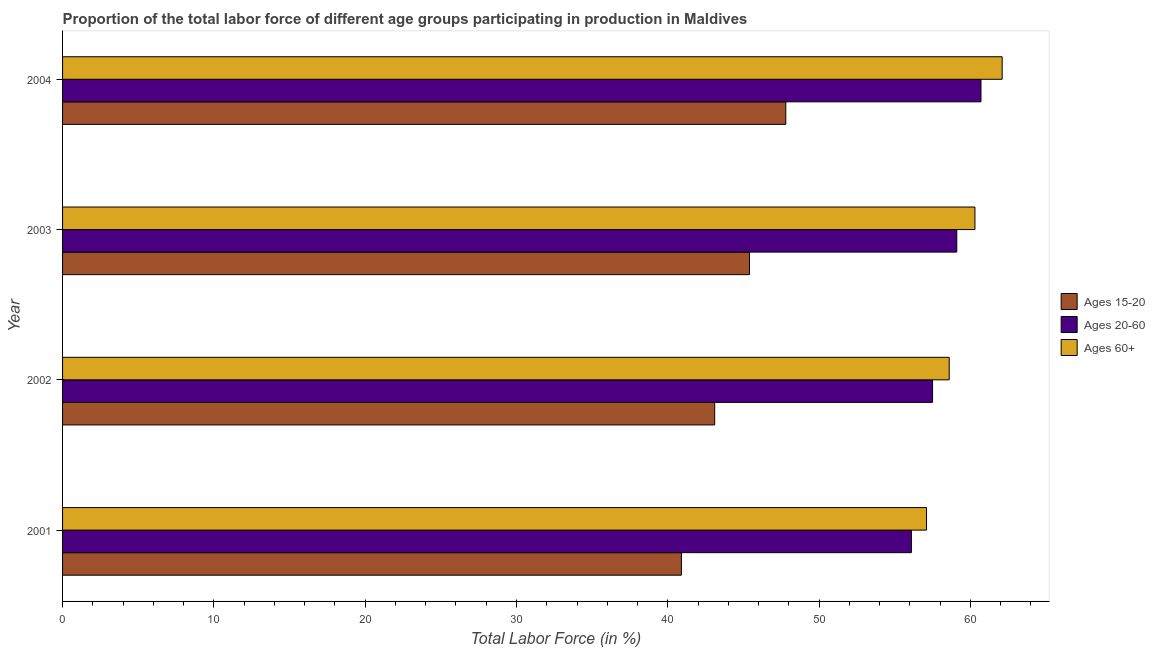Are the number of bars on each tick of the Y-axis equal?
Offer a very short reply. Yes. What is the label of the 2nd group of bars from the top?
Offer a very short reply. 2003. What is the percentage of labor force within the age group 15-20 in 2004?
Your answer should be compact. 47.8. Across all years, what is the maximum percentage of labor force above age 60?
Make the answer very short. 62.1. Across all years, what is the minimum percentage of labor force above age 60?
Offer a very short reply. 57.1. In which year was the percentage of labor force within the age group 15-20 minimum?
Your response must be concise. 2001. What is the total percentage of labor force within the age group 20-60 in the graph?
Your answer should be compact. 233.4. What is the difference between the percentage of labor force within the age group 15-20 in 2003 and that in 2004?
Give a very brief answer. -2.4. What is the difference between the percentage of labor force within the age group 15-20 in 2001 and the percentage of labor force above age 60 in 2003?
Provide a short and direct response. -19.4. What is the average percentage of labor force within the age group 20-60 per year?
Offer a very short reply. 58.35. In the year 2001, what is the difference between the percentage of labor force above age 60 and percentage of labor force within the age group 20-60?
Your answer should be very brief. 1. In how many years, is the percentage of labor force above age 60 greater than 20 %?
Make the answer very short. 4. What is the ratio of the percentage of labor force within the age group 20-60 in 2002 to that in 2003?
Keep it short and to the point. 0.97. What is the difference between the highest and the lowest percentage of labor force within the age group 15-20?
Your answer should be very brief. 6.9. What does the 1st bar from the top in 2003 represents?
Offer a terse response. Ages 60+. What does the 1st bar from the bottom in 2003 represents?
Offer a very short reply. Ages 15-20. How many bars are there?
Offer a very short reply. 12. What is the difference between two consecutive major ticks on the X-axis?
Give a very brief answer. 10. Does the graph contain any zero values?
Provide a short and direct response. No. Does the graph contain grids?
Keep it short and to the point. No. How many legend labels are there?
Your answer should be very brief. 3. How are the legend labels stacked?
Offer a very short reply. Vertical. What is the title of the graph?
Your response must be concise. Proportion of the total labor force of different age groups participating in production in Maldives. What is the label or title of the X-axis?
Provide a succinct answer. Total Labor Force (in %). What is the label or title of the Y-axis?
Make the answer very short. Year. What is the Total Labor Force (in %) in Ages 15-20 in 2001?
Ensure brevity in your answer.  40.9. What is the Total Labor Force (in %) in Ages 20-60 in 2001?
Give a very brief answer. 56.1. What is the Total Labor Force (in %) in Ages 60+ in 2001?
Provide a short and direct response. 57.1. What is the Total Labor Force (in %) of Ages 15-20 in 2002?
Your response must be concise. 43.1. What is the Total Labor Force (in %) in Ages 20-60 in 2002?
Keep it short and to the point. 57.5. What is the Total Labor Force (in %) in Ages 60+ in 2002?
Your answer should be compact. 58.6. What is the Total Labor Force (in %) in Ages 15-20 in 2003?
Make the answer very short. 45.4. What is the Total Labor Force (in %) in Ages 20-60 in 2003?
Offer a very short reply. 59.1. What is the Total Labor Force (in %) of Ages 60+ in 2003?
Give a very brief answer. 60.3. What is the Total Labor Force (in %) in Ages 15-20 in 2004?
Your response must be concise. 47.8. What is the Total Labor Force (in %) of Ages 20-60 in 2004?
Give a very brief answer. 60.7. What is the Total Labor Force (in %) in Ages 60+ in 2004?
Provide a succinct answer. 62.1. Across all years, what is the maximum Total Labor Force (in %) in Ages 15-20?
Make the answer very short. 47.8. Across all years, what is the maximum Total Labor Force (in %) in Ages 20-60?
Your answer should be very brief. 60.7. Across all years, what is the maximum Total Labor Force (in %) of Ages 60+?
Provide a short and direct response. 62.1. Across all years, what is the minimum Total Labor Force (in %) in Ages 15-20?
Offer a very short reply. 40.9. Across all years, what is the minimum Total Labor Force (in %) in Ages 20-60?
Provide a short and direct response. 56.1. Across all years, what is the minimum Total Labor Force (in %) of Ages 60+?
Give a very brief answer. 57.1. What is the total Total Labor Force (in %) of Ages 15-20 in the graph?
Offer a very short reply. 177.2. What is the total Total Labor Force (in %) of Ages 20-60 in the graph?
Provide a succinct answer. 233.4. What is the total Total Labor Force (in %) in Ages 60+ in the graph?
Offer a terse response. 238.1. What is the difference between the Total Labor Force (in %) of Ages 20-60 in 2001 and that in 2002?
Ensure brevity in your answer.  -1.4. What is the difference between the Total Labor Force (in %) in Ages 20-60 in 2001 and that in 2003?
Your answer should be compact. -3. What is the difference between the Total Labor Force (in %) of Ages 60+ in 2001 and that in 2004?
Provide a succinct answer. -5. What is the difference between the Total Labor Force (in %) of Ages 20-60 in 2002 and that in 2004?
Your response must be concise. -3.2. What is the difference between the Total Labor Force (in %) of Ages 15-20 in 2003 and that in 2004?
Your answer should be very brief. -2.4. What is the difference between the Total Labor Force (in %) in Ages 20-60 in 2003 and that in 2004?
Offer a terse response. -1.6. What is the difference between the Total Labor Force (in %) of Ages 15-20 in 2001 and the Total Labor Force (in %) of Ages 20-60 in 2002?
Make the answer very short. -16.6. What is the difference between the Total Labor Force (in %) of Ages 15-20 in 2001 and the Total Labor Force (in %) of Ages 60+ in 2002?
Provide a short and direct response. -17.7. What is the difference between the Total Labor Force (in %) in Ages 15-20 in 2001 and the Total Labor Force (in %) in Ages 20-60 in 2003?
Offer a very short reply. -18.2. What is the difference between the Total Labor Force (in %) of Ages 15-20 in 2001 and the Total Labor Force (in %) of Ages 60+ in 2003?
Keep it short and to the point. -19.4. What is the difference between the Total Labor Force (in %) in Ages 20-60 in 2001 and the Total Labor Force (in %) in Ages 60+ in 2003?
Ensure brevity in your answer.  -4.2. What is the difference between the Total Labor Force (in %) in Ages 15-20 in 2001 and the Total Labor Force (in %) in Ages 20-60 in 2004?
Your response must be concise. -19.8. What is the difference between the Total Labor Force (in %) in Ages 15-20 in 2001 and the Total Labor Force (in %) in Ages 60+ in 2004?
Provide a succinct answer. -21.2. What is the difference between the Total Labor Force (in %) of Ages 20-60 in 2001 and the Total Labor Force (in %) of Ages 60+ in 2004?
Your answer should be compact. -6. What is the difference between the Total Labor Force (in %) of Ages 15-20 in 2002 and the Total Labor Force (in %) of Ages 20-60 in 2003?
Provide a short and direct response. -16. What is the difference between the Total Labor Force (in %) in Ages 15-20 in 2002 and the Total Labor Force (in %) in Ages 60+ in 2003?
Your answer should be compact. -17.2. What is the difference between the Total Labor Force (in %) in Ages 20-60 in 2002 and the Total Labor Force (in %) in Ages 60+ in 2003?
Provide a succinct answer. -2.8. What is the difference between the Total Labor Force (in %) of Ages 15-20 in 2002 and the Total Labor Force (in %) of Ages 20-60 in 2004?
Provide a short and direct response. -17.6. What is the difference between the Total Labor Force (in %) in Ages 15-20 in 2002 and the Total Labor Force (in %) in Ages 60+ in 2004?
Offer a terse response. -19. What is the difference between the Total Labor Force (in %) in Ages 20-60 in 2002 and the Total Labor Force (in %) in Ages 60+ in 2004?
Make the answer very short. -4.6. What is the difference between the Total Labor Force (in %) of Ages 15-20 in 2003 and the Total Labor Force (in %) of Ages 20-60 in 2004?
Offer a very short reply. -15.3. What is the difference between the Total Labor Force (in %) of Ages 15-20 in 2003 and the Total Labor Force (in %) of Ages 60+ in 2004?
Provide a short and direct response. -16.7. What is the average Total Labor Force (in %) in Ages 15-20 per year?
Offer a terse response. 44.3. What is the average Total Labor Force (in %) in Ages 20-60 per year?
Give a very brief answer. 58.35. What is the average Total Labor Force (in %) of Ages 60+ per year?
Offer a very short reply. 59.52. In the year 2001, what is the difference between the Total Labor Force (in %) in Ages 15-20 and Total Labor Force (in %) in Ages 20-60?
Provide a succinct answer. -15.2. In the year 2001, what is the difference between the Total Labor Force (in %) of Ages 15-20 and Total Labor Force (in %) of Ages 60+?
Give a very brief answer. -16.2. In the year 2002, what is the difference between the Total Labor Force (in %) of Ages 15-20 and Total Labor Force (in %) of Ages 20-60?
Ensure brevity in your answer.  -14.4. In the year 2002, what is the difference between the Total Labor Force (in %) of Ages 15-20 and Total Labor Force (in %) of Ages 60+?
Your answer should be compact. -15.5. In the year 2003, what is the difference between the Total Labor Force (in %) in Ages 15-20 and Total Labor Force (in %) in Ages 20-60?
Provide a short and direct response. -13.7. In the year 2003, what is the difference between the Total Labor Force (in %) of Ages 15-20 and Total Labor Force (in %) of Ages 60+?
Give a very brief answer. -14.9. In the year 2004, what is the difference between the Total Labor Force (in %) in Ages 15-20 and Total Labor Force (in %) in Ages 20-60?
Your answer should be very brief. -12.9. In the year 2004, what is the difference between the Total Labor Force (in %) in Ages 15-20 and Total Labor Force (in %) in Ages 60+?
Your answer should be compact. -14.3. In the year 2004, what is the difference between the Total Labor Force (in %) in Ages 20-60 and Total Labor Force (in %) in Ages 60+?
Your answer should be compact. -1.4. What is the ratio of the Total Labor Force (in %) in Ages 15-20 in 2001 to that in 2002?
Keep it short and to the point. 0.95. What is the ratio of the Total Labor Force (in %) of Ages 20-60 in 2001 to that in 2002?
Keep it short and to the point. 0.98. What is the ratio of the Total Labor Force (in %) in Ages 60+ in 2001 to that in 2002?
Keep it short and to the point. 0.97. What is the ratio of the Total Labor Force (in %) of Ages 15-20 in 2001 to that in 2003?
Your answer should be very brief. 0.9. What is the ratio of the Total Labor Force (in %) of Ages 20-60 in 2001 to that in 2003?
Provide a succinct answer. 0.95. What is the ratio of the Total Labor Force (in %) of Ages 60+ in 2001 to that in 2003?
Your response must be concise. 0.95. What is the ratio of the Total Labor Force (in %) of Ages 15-20 in 2001 to that in 2004?
Offer a terse response. 0.86. What is the ratio of the Total Labor Force (in %) of Ages 20-60 in 2001 to that in 2004?
Your answer should be very brief. 0.92. What is the ratio of the Total Labor Force (in %) in Ages 60+ in 2001 to that in 2004?
Your answer should be compact. 0.92. What is the ratio of the Total Labor Force (in %) in Ages 15-20 in 2002 to that in 2003?
Provide a succinct answer. 0.95. What is the ratio of the Total Labor Force (in %) of Ages 20-60 in 2002 to that in 2003?
Offer a terse response. 0.97. What is the ratio of the Total Labor Force (in %) in Ages 60+ in 2002 to that in 2003?
Make the answer very short. 0.97. What is the ratio of the Total Labor Force (in %) of Ages 15-20 in 2002 to that in 2004?
Offer a very short reply. 0.9. What is the ratio of the Total Labor Force (in %) of Ages 20-60 in 2002 to that in 2004?
Offer a very short reply. 0.95. What is the ratio of the Total Labor Force (in %) of Ages 60+ in 2002 to that in 2004?
Provide a succinct answer. 0.94. What is the ratio of the Total Labor Force (in %) in Ages 15-20 in 2003 to that in 2004?
Offer a very short reply. 0.95. What is the ratio of the Total Labor Force (in %) of Ages 20-60 in 2003 to that in 2004?
Provide a succinct answer. 0.97. What is the difference between the highest and the second highest Total Labor Force (in %) in Ages 15-20?
Your answer should be very brief. 2.4. What is the difference between the highest and the second highest Total Labor Force (in %) in Ages 60+?
Give a very brief answer. 1.8. What is the difference between the highest and the lowest Total Labor Force (in %) in Ages 20-60?
Provide a short and direct response. 4.6. 